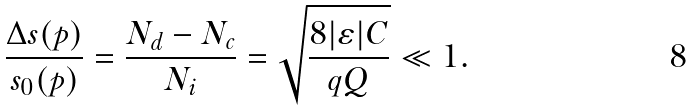Convert formula to latex. <formula><loc_0><loc_0><loc_500><loc_500>\frac { \Delta s ( p ) } { s _ { 0 } ( p ) } = \frac { N _ { d } - N _ { c } } { N _ { i } } = \sqrt { \frac { 8 | \varepsilon | C } { q Q } } \ll 1 .</formula> 